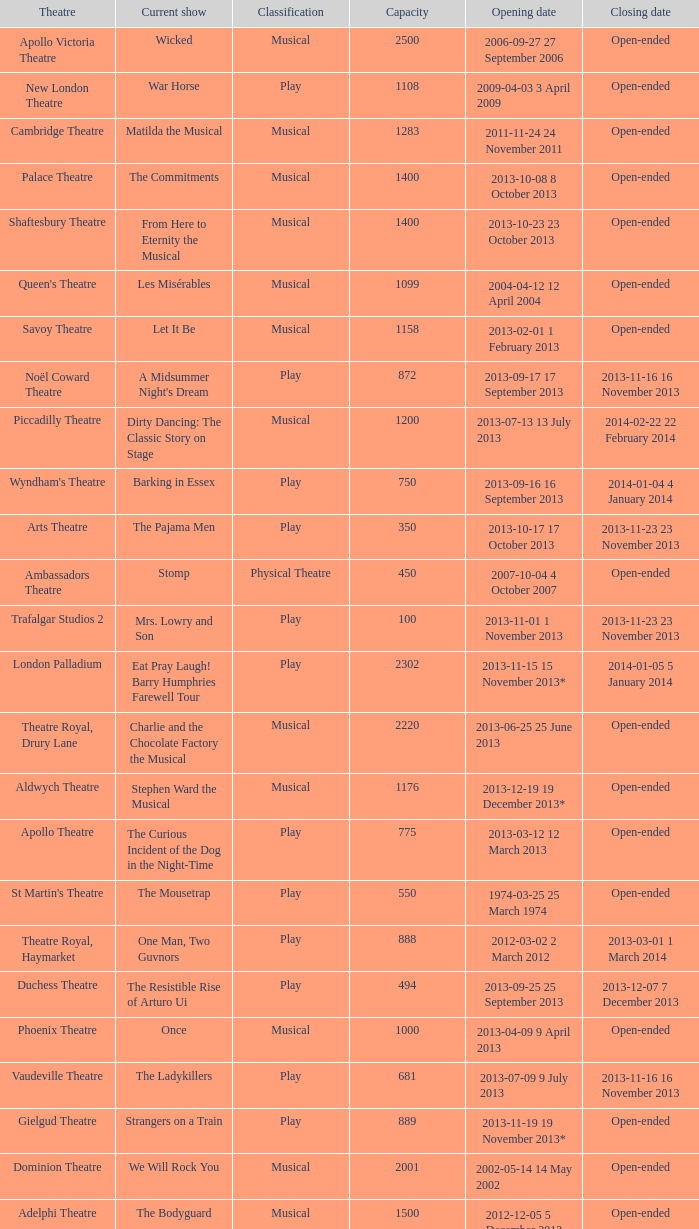What is the opening date of the musical at the adelphi theatre? 2012-12-05 5 December 2012. 